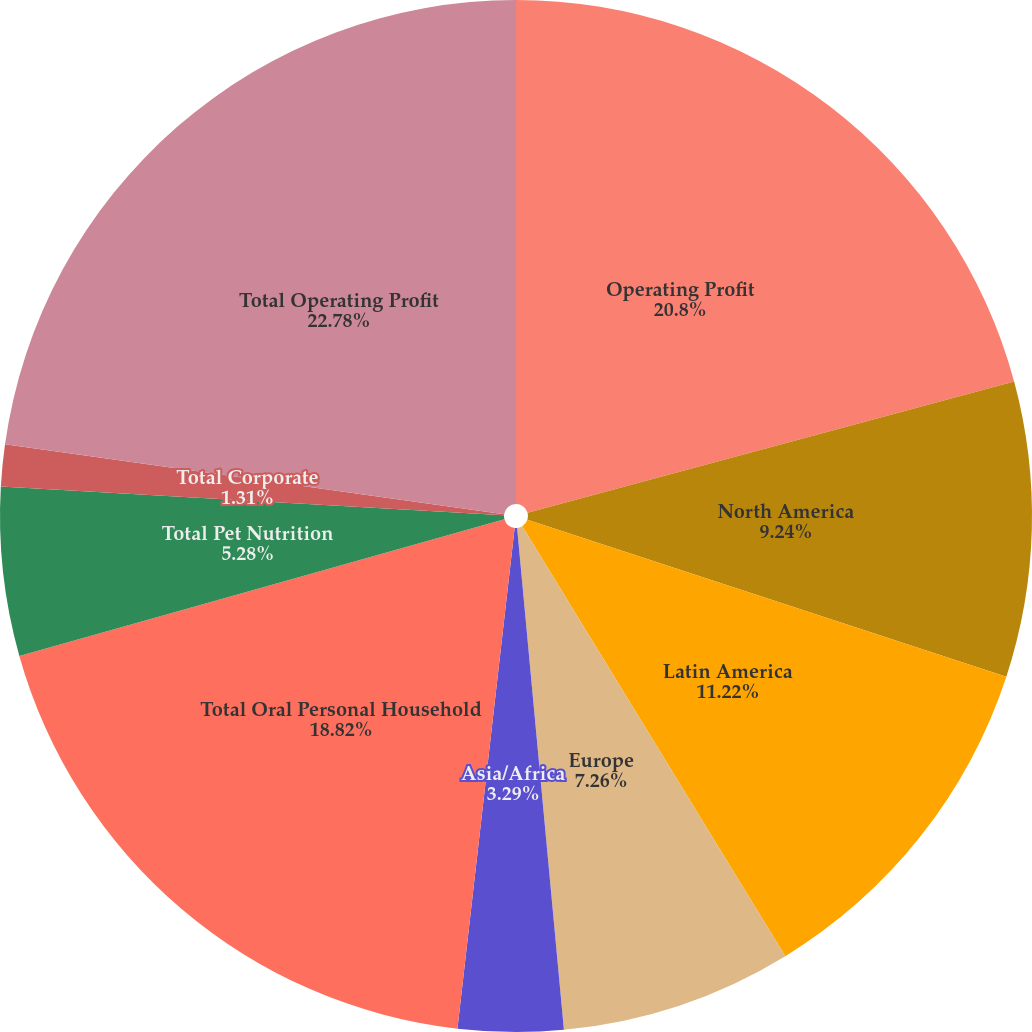Convert chart. <chart><loc_0><loc_0><loc_500><loc_500><pie_chart><fcel>Operating Profit<fcel>North America<fcel>Latin America<fcel>Europe<fcel>Asia/Africa<fcel>Total Oral Personal Household<fcel>Total Pet Nutrition<fcel>Total Corporate<fcel>Total Operating Profit<nl><fcel>20.8%<fcel>9.24%<fcel>11.22%<fcel>7.26%<fcel>3.29%<fcel>18.82%<fcel>5.28%<fcel>1.31%<fcel>22.78%<nl></chart> 